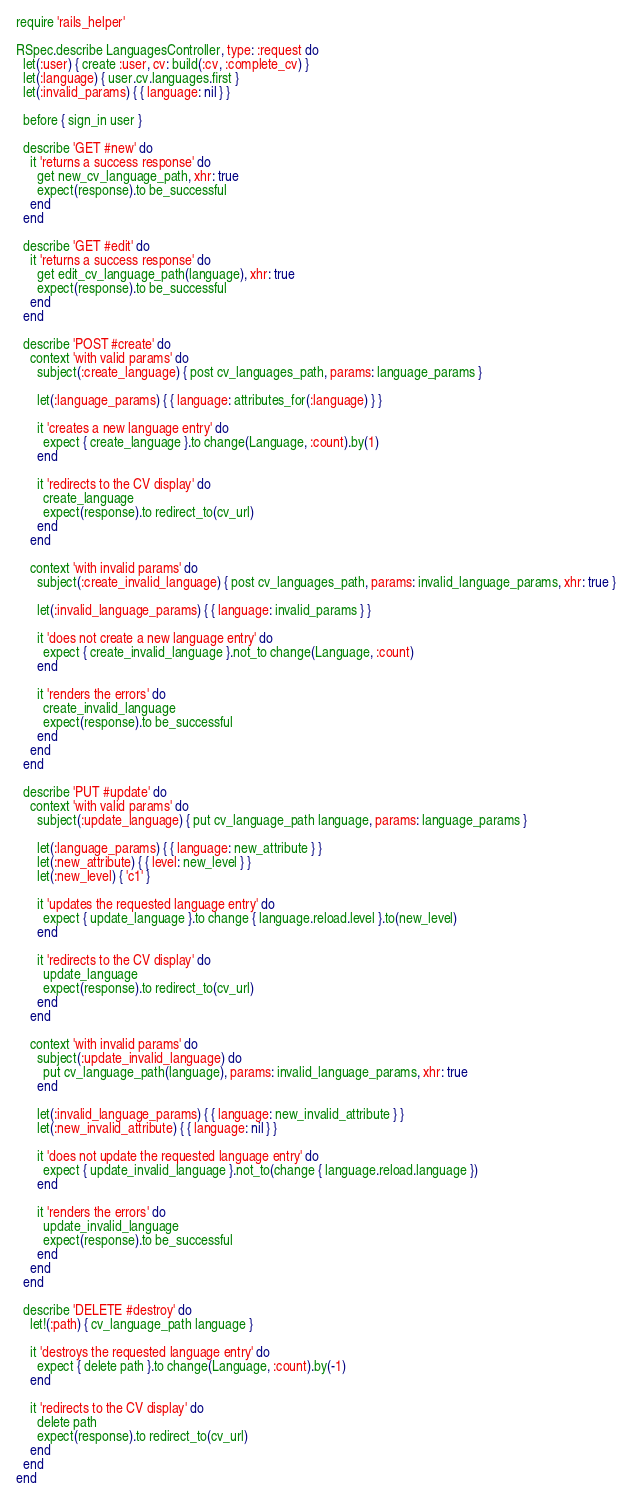<code> <loc_0><loc_0><loc_500><loc_500><_Ruby_>require 'rails_helper'

RSpec.describe LanguagesController, type: :request do
  let(:user) { create :user, cv: build(:cv, :complete_cv) }
  let(:language) { user.cv.languages.first }
  let(:invalid_params) { { language: nil } }

  before { sign_in user }

  describe 'GET #new' do
    it 'returns a success response' do
      get new_cv_language_path, xhr: true
      expect(response).to be_successful
    end
  end

  describe 'GET #edit' do
    it 'returns a success response' do
      get edit_cv_language_path(language), xhr: true
      expect(response).to be_successful
    end
  end

  describe 'POST #create' do
    context 'with valid params' do
      subject(:create_language) { post cv_languages_path, params: language_params }

      let(:language_params) { { language: attributes_for(:language) } }

      it 'creates a new language entry' do
        expect { create_language }.to change(Language, :count).by(1)
      end

      it 'redirects to the CV display' do
        create_language
        expect(response).to redirect_to(cv_url)
      end
    end

    context 'with invalid params' do
      subject(:create_invalid_language) { post cv_languages_path, params: invalid_language_params, xhr: true }

      let(:invalid_language_params) { { language: invalid_params } }

      it 'does not create a new language entry' do
        expect { create_invalid_language }.not_to change(Language, :count)
      end

      it 'renders the errors' do
        create_invalid_language
        expect(response).to be_successful
      end
    end
  end

  describe 'PUT #update' do
    context 'with valid params' do
      subject(:update_language) { put cv_language_path language, params: language_params }

      let(:language_params) { { language: new_attribute } }
      let(:new_attribute) { { level: new_level } }
      let(:new_level) { 'c1' }

      it 'updates the requested language entry' do
        expect { update_language }.to change { language.reload.level }.to(new_level)
      end

      it 'redirects to the CV display' do
        update_language
        expect(response).to redirect_to(cv_url)
      end
    end

    context 'with invalid params' do
      subject(:update_invalid_language) do
        put cv_language_path(language), params: invalid_language_params, xhr: true
      end

      let(:invalid_language_params) { { language: new_invalid_attribute } }
      let(:new_invalid_attribute) { { language: nil } }

      it 'does not update the requested language entry' do
        expect { update_invalid_language }.not_to(change { language.reload.language })
      end

      it 'renders the errors' do
        update_invalid_language
        expect(response).to be_successful
      end
    end
  end

  describe 'DELETE #destroy' do
    let!(:path) { cv_language_path language }

    it 'destroys the requested language entry' do
      expect { delete path }.to change(Language, :count).by(-1)
    end

    it 'redirects to the CV display' do
      delete path
      expect(response).to redirect_to(cv_url)
    end
  end
end
</code> 